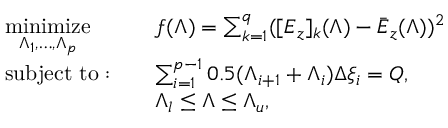<formula> <loc_0><loc_0><loc_500><loc_500>\begin{array} { r l r l } & { \underset { \Lambda _ { 1 } , \dots , \Lambda _ { p } } { \min i m i z e } } & & { f ( \Lambda ) = \sum _ { k = 1 } ^ { q } ( [ E _ { z } ] _ { k } ( \Lambda ) - \bar { E } _ { z } ( \Lambda ) ) ^ { 2 } } \\ & { s u b j e c t t o \colon } & & { \sum _ { i = 1 } ^ { p - 1 } 0 . 5 ( \Lambda _ { i + 1 } + \Lambda _ { i } ) \Delta \xi _ { i } = Q , } \\ & & { \Lambda _ { l } \leq \Lambda \leq \Lambda _ { u } , } \end{array}</formula> 